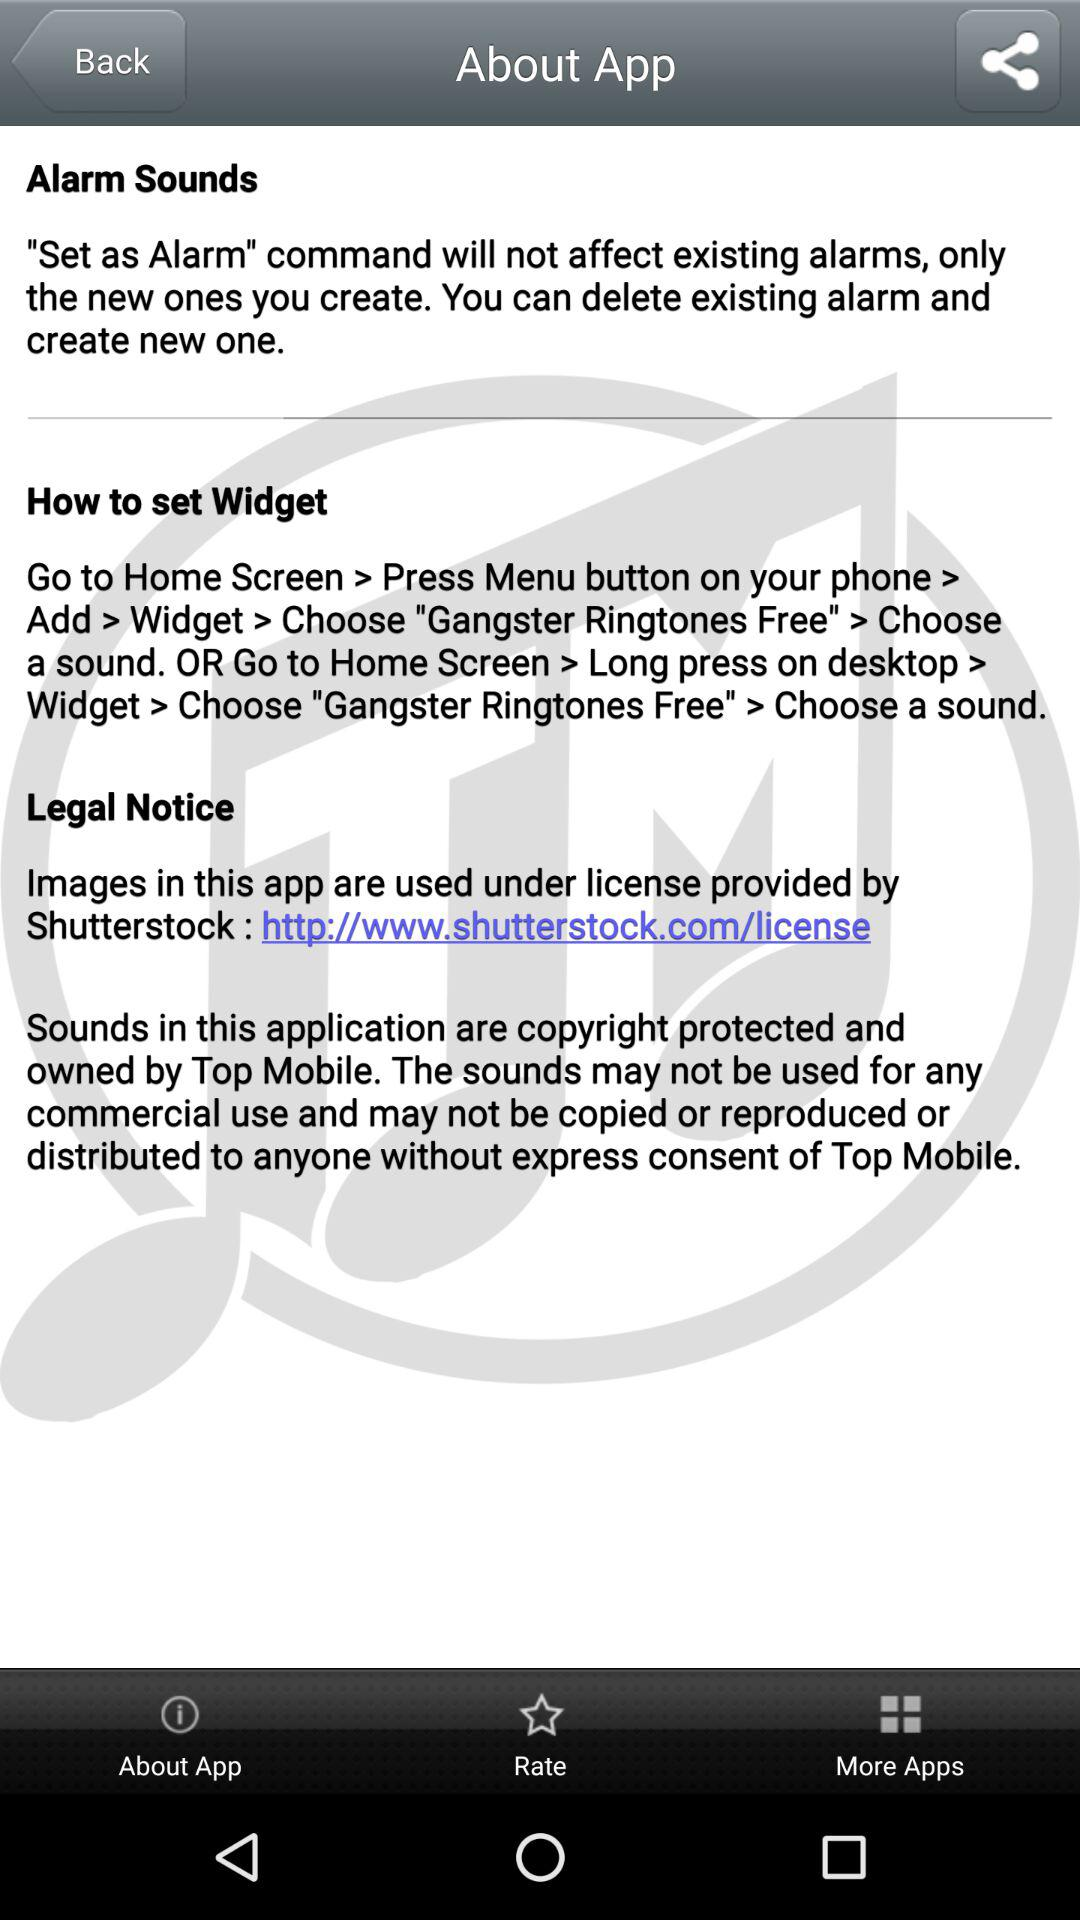What is the license link mentioned? The license link that is mentioned is "http://www.shutterstock.com/license". 